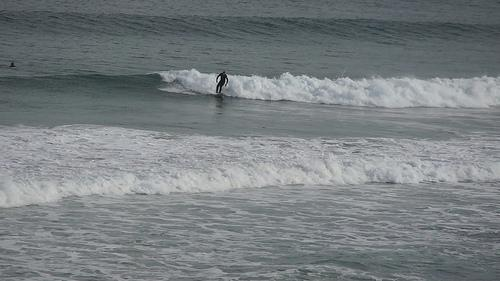Question: what is the man doing?
Choices:
A. The man is driving.
B. The man is surfing.
C. The man is laughing.
D. The man is chatting.
Answer with the letter. Answer: B Question: why is the man in motion?
Choices:
A. He is biking.
B. He is driving.
C. He is riding a moped.
D. Because he is on a surfboard.
Answer with the letter. Answer: D Question: where was this photo taken?
Choices:
A. The lake.
B. The river.
C. The downtown.
D. The beach.
Answer with the letter. Answer: D Question: who is in this photo?
Choices:
A. A woman.
B. A boy.
C. A girl.
D. A man.
Answer with the letter. Answer: D 